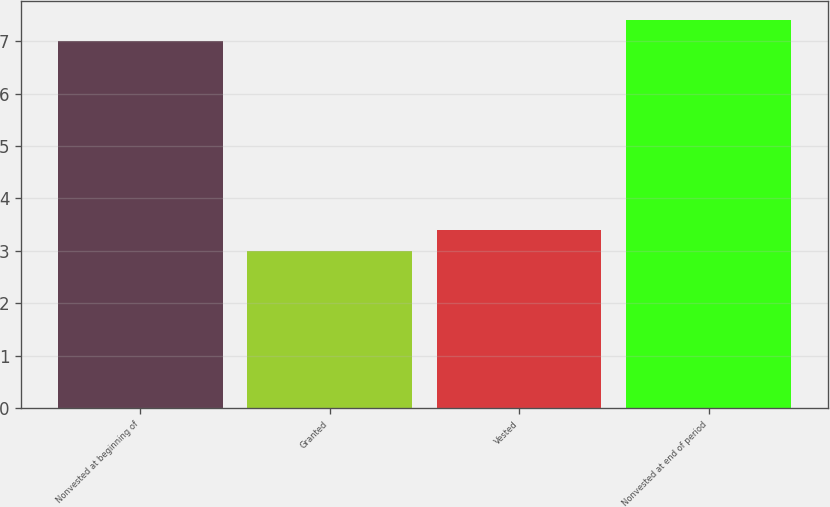<chart> <loc_0><loc_0><loc_500><loc_500><bar_chart><fcel>Nonvested at beginning of<fcel>Granted<fcel>Vested<fcel>Nonvested at end of period<nl><fcel>7<fcel>3<fcel>3.4<fcel>7.4<nl></chart> 